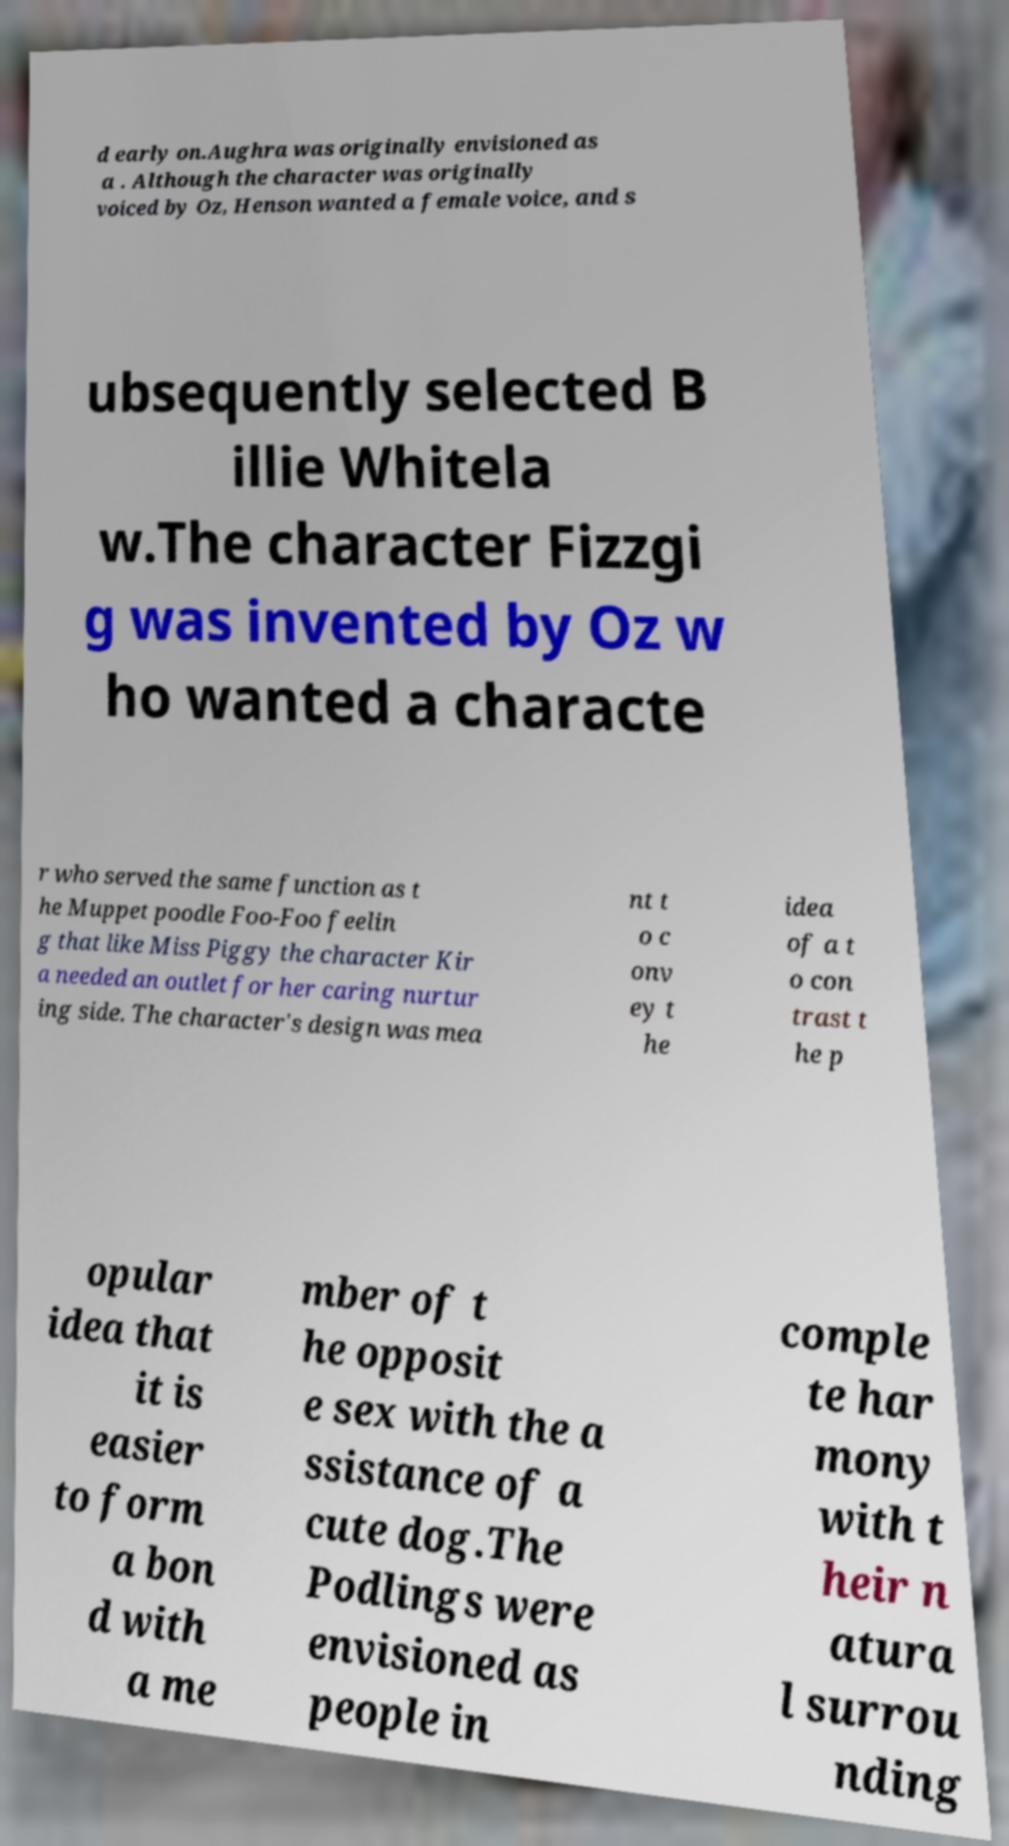For documentation purposes, I need the text within this image transcribed. Could you provide that? d early on.Aughra was originally envisioned as a . Although the character was originally voiced by Oz, Henson wanted a female voice, and s ubsequently selected B illie Whitela w.The character Fizzgi g was invented by Oz w ho wanted a characte r who served the same function as t he Muppet poodle Foo-Foo feelin g that like Miss Piggy the character Kir a needed an outlet for her caring nurtur ing side. The character's design was mea nt t o c onv ey t he idea of a t o con trast t he p opular idea that it is easier to form a bon d with a me mber of t he opposit e sex with the a ssistance of a cute dog.The Podlings were envisioned as people in comple te har mony with t heir n atura l surrou nding 